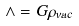Convert formula to latex. <formula><loc_0><loc_0><loc_500><loc_500>\wedge = G \rho _ { v a c }</formula> 